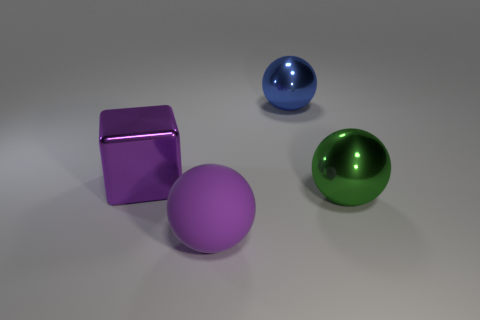Are there any other things that are made of the same material as the large purple sphere?
Your answer should be compact. No. What is the shape of the big thing that is behind the purple thing behind the green metallic ball?
Offer a very short reply. Sphere. The large thing that is behind the cube is what color?
Provide a short and direct response. Blue. The other matte thing that is the same shape as the blue object is what size?
Offer a terse response. Large. Are any small green metal objects visible?
Make the answer very short. No. What number of things are large metal objects that are on the left side of the blue metal object or big cyan blocks?
Offer a terse response. 1. There is a purple object that is the same size as the rubber sphere; what material is it?
Your answer should be very brief. Metal. The large sphere that is in front of the large shiny ball that is to the right of the blue sphere is what color?
Offer a very short reply. Purple. What number of large green metallic balls are in front of the purple sphere?
Your response must be concise. 0. The metallic cube has what color?
Give a very brief answer. Purple. 